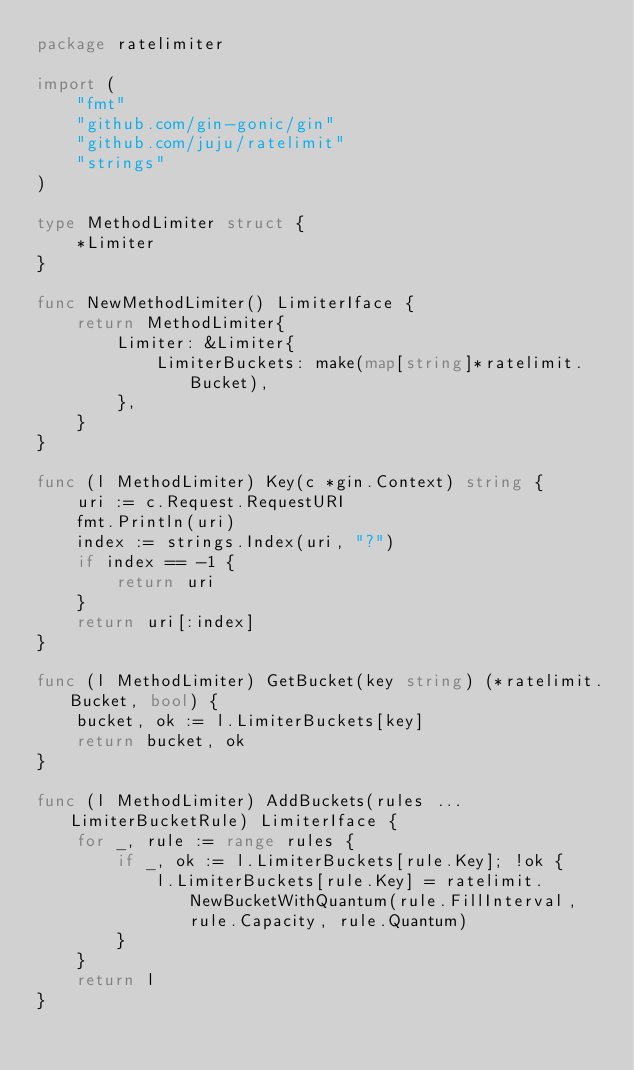Convert code to text. <code><loc_0><loc_0><loc_500><loc_500><_Go_>package ratelimiter

import (
	"fmt"
	"github.com/gin-gonic/gin"
	"github.com/juju/ratelimit"
	"strings"
)

type MethodLimiter struct {
	*Limiter
}

func NewMethodLimiter() LimiterIface {
	return MethodLimiter{
		Limiter: &Limiter{
			LimiterBuckets: make(map[string]*ratelimit.Bucket),
		},
	}
}

func (l MethodLimiter) Key(c *gin.Context) string {
	uri := c.Request.RequestURI
	fmt.Println(uri)
	index := strings.Index(uri, "?")
	if index == -1 {
		return uri
	}
	return uri[:index]
}

func (l MethodLimiter) GetBucket(key string) (*ratelimit.Bucket, bool) {
	bucket, ok := l.LimiterBuckets[key]
	return bucket, ok
}

func (l MethodLimiter) AddBuckets(rules ...LimiterBucketRule) LimiterIface {
	for _, rule := range rules {
		if _, ok := l.LimiterBuckets[rule.Key]; !ok {
			l.LimiterBuckets[rule.Key] = ratelimit.NewBucketWithQuantum(rule.FillInterval, rule.Capacity, rule.Quantum)
		}
	}
	return l
}
</code> 